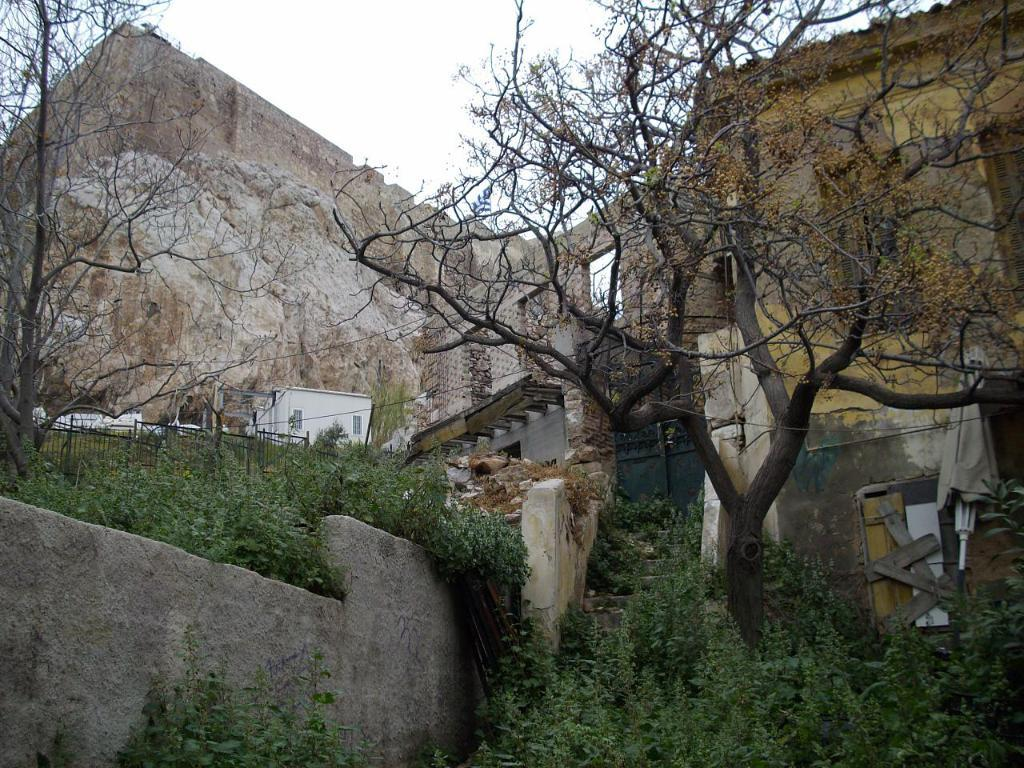What type of structures can be seen in the image? There are houses in the image. What natural elements are present in the image? There are trees, plants, rocks, and the sky visible in the image. Can you describe any man-made structures in the image? There is a railing in the image. What is visible in the background of the image? There is a wall and the sky visible in the background of the image. What type of popcorn can be seen floating in space in the image? There is no popcorn or space present in the image. How does the transport system operate in the image? There is no transport system depicted in the image. 